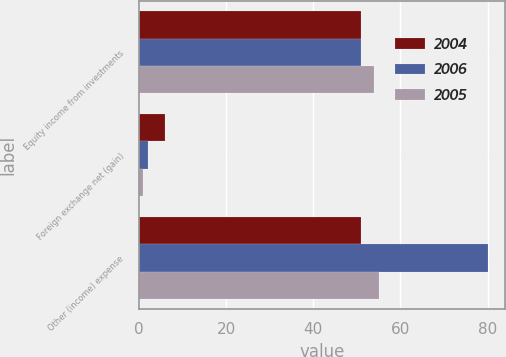Convert chart. <chart><loc_0><loc_0><loc_500><loc_500><stacked_bar_chart><ecel><fcel>Equity income from investments<fcel>Foreign exchange net (gain)<fcel>Other (income) expense<nl><fcel>2004<fcel>51<fcel>6<fcel>51<nl><fcel>2006<fcel>51<fcel>2<fcel>80<nl><fcel>2005<fcel>54<fcel>1<fcel>55<nl></chart> 